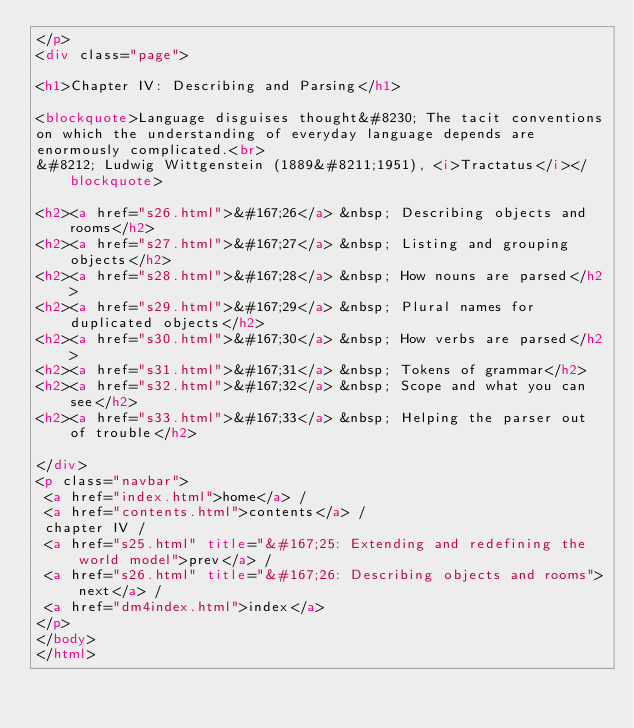Convert code to text. <code><loc_0><loc_0><loc_500><loc_500><_HTML_></p>
<div class="page">

<h1>Chapter IV: Describing and Parsing</h1>

<blockquote>Language disguises thought&#8230; The tacit conventions 
on which the understanding of everyday language depends are 
enormously complicated.<br>
&#8212; Ludwig Wittgenstein (1889&#8211;1951), <i>Tractatus</i></blockquote>

<h2><a href="s26.html">&#167;26</a> &nbsp; Describing objects and rooms</h2>
<h2><a href="s27.html">&#167;27</a> &nbsp; Listing and grouping objects</h2>
<h2><a href="s28.html">&#167;28</a> &nbsp; How nouns are parsed</h2>
<h2><a href="s29.html">&#167;29</a> &nbsp; Plural names for duplicated objects</h2>
<h2><a href="s30.html">&#167;30</a> &nbsp; How verbs are parsed</h2>
<h2><a href="s31.html">&#167;31</a> &nbsp; Tokens of grammar</h2>
<h2><a href="s32.html">&#167;32</a> &nbsp; Scope and what you can see</h2>
<h2><a href="s33.html">&#167;33</a> &nbsp; Helping the parser out of trouble</h2>

</div>
<p class="navbar">
 <a href="index.html">home</a> /
 <a href="contents.html">contents</a> /
 chapter IV /
 <a href="s25.html" title="&#167;25: Extending and redefining the world model">prev</a> /
 <a href="s26.html" title="&#167;26: Describing objects and rooms">next</a> /
 <a href="dm4index.html">index</a>
</p>
</body>
</html>
</code> 